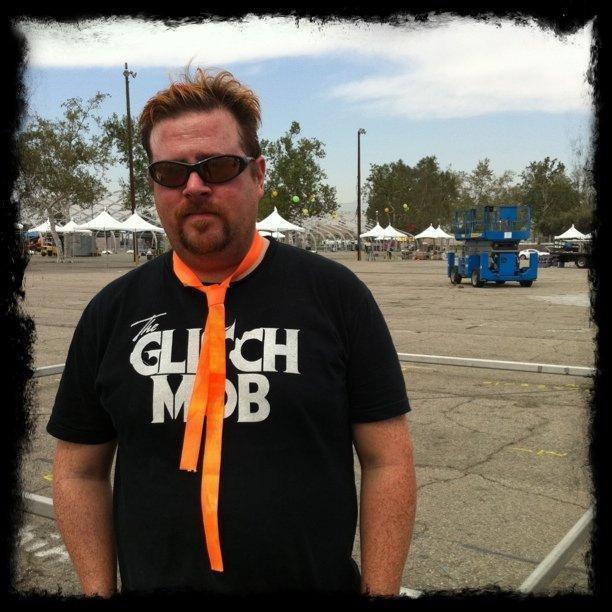How many ties can be seen?
Give a very brief answer. 1. How many floor tiles with any part of a cat on them are in the picture?
Give a very brief answer. 0. 